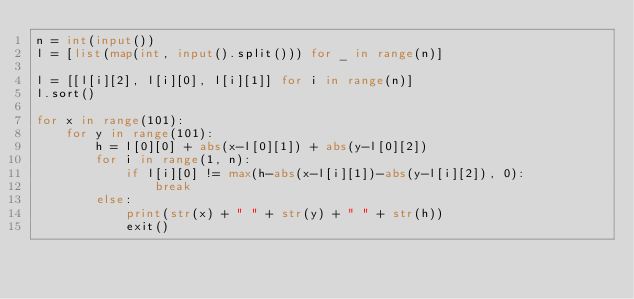Convert code to text. <code><loc_0><loc_0><loc_500><loc_500><_Python_>n = int(input())
l = [list(map(int, input().split())) for _ in range(n)]

l = [[l[i][2], l[i][0], l[i][1]] for i in range(n)]
l.sort()

for x in range(101):
    for y in range(101):
        h = l[0][0] + abs(x-l[0][1]) + abs(y-l[0][2])
        for i in range(1, n):
            if l[i][0] != max(h-abs(x-l[i][1])-abs(y-l[i][2]), 0):
                break
        else:
            print(str(x) + " " + str(y) + " " + str(h))
            exit()</code> 